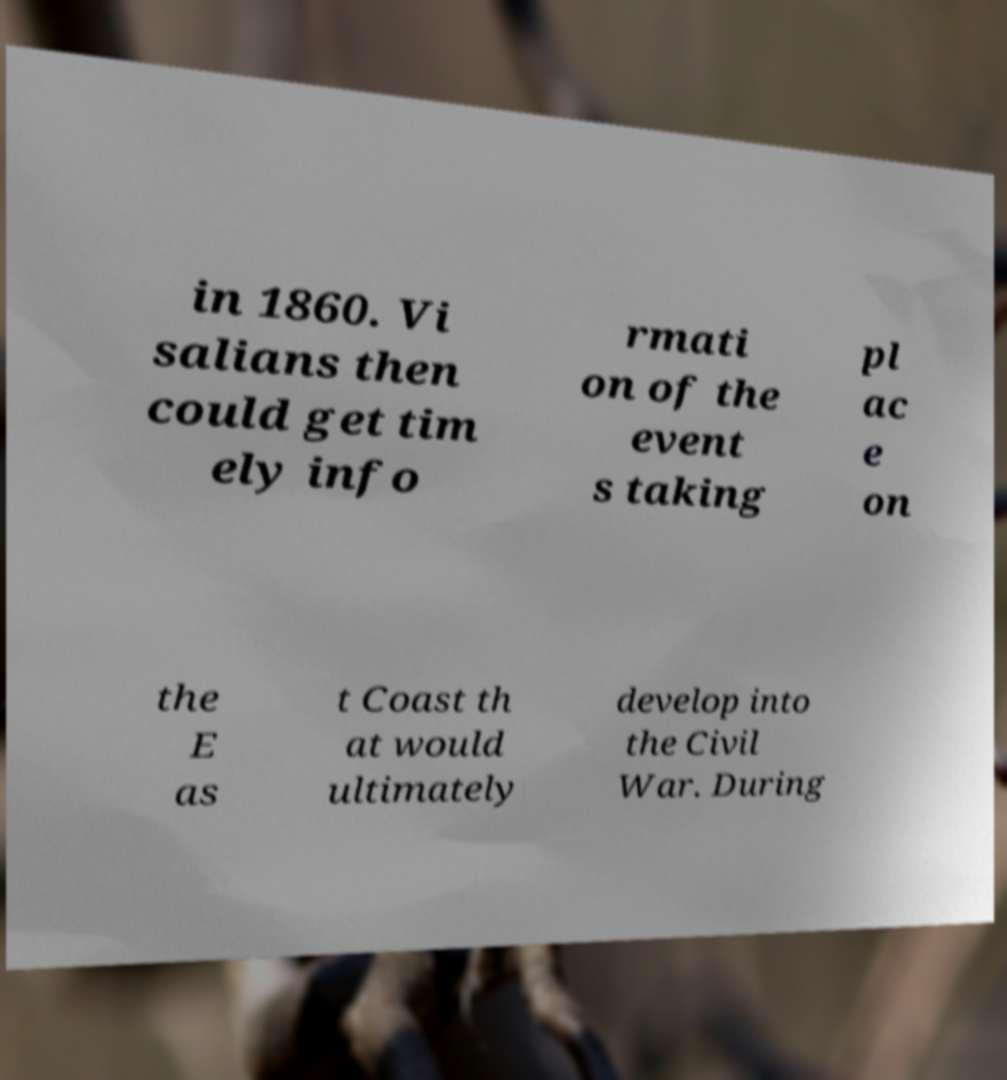Could you assist in decoding the text presented in this image and type it out clearly? in 1860. Vi salians then could get tim ely info rmati on of the event s taking pl ac e on the E as t Coast th at would ultimately develop into the Civil War. During 